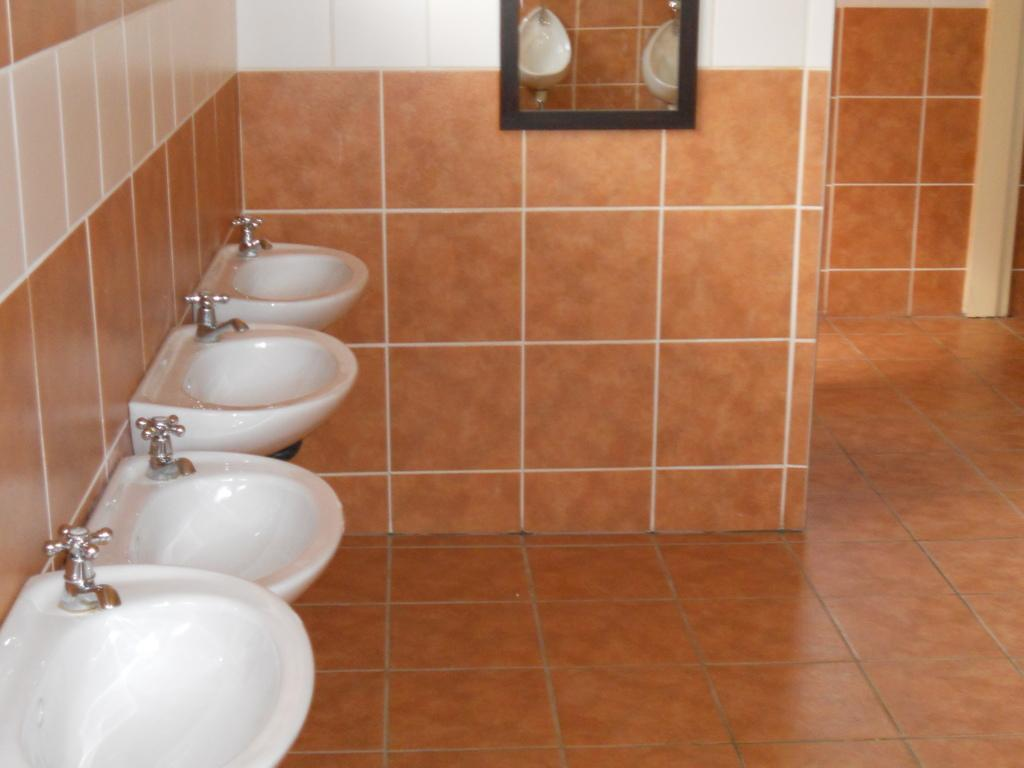What type of fixtures are present in the image? There are washbasins in the image. What can be seen on the wall in the image? There is a mirror on the wall in the image. What type of vessel is being used to make an attempt to end the mirror's existence in the image? There is no vessel or attempt to end the mirror's existence in the image; it is simply hanging on the wall. 